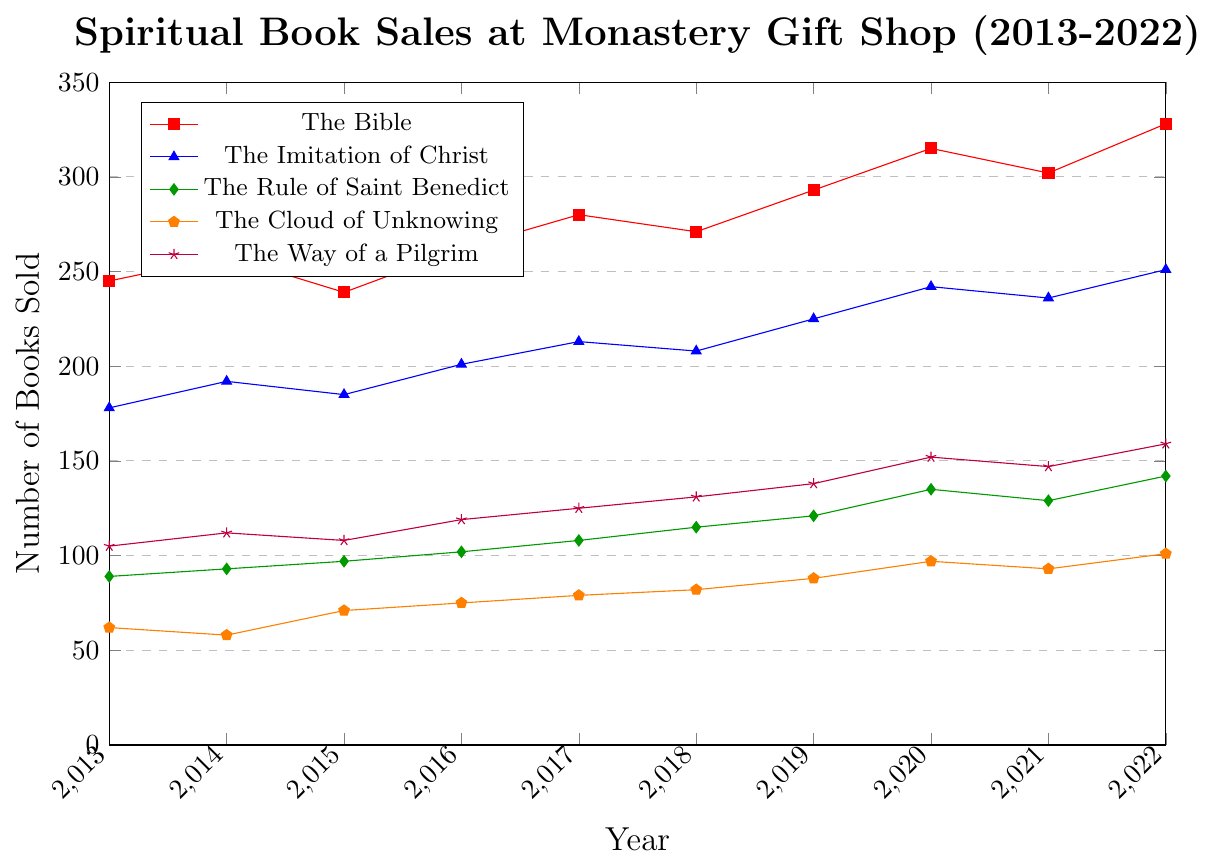What was the difference in sales of "The Bible" between 2013 and 2022? To find the difference, subtract the number of books sold in 2013 from the number of books sold in 2022. The values are 328 in 2022 and 245 in 2013. Therefore, 328 - 245 = 83.
Answer: 83 Which book had the highest sales in 2020 and how many were sold? Scan through the data points for the year 2020. "The Bible" had the highest sales at 315 units.
Answer: The Bible, 315 What was the average number of "The Rule of Saint Benedict" books sold per year over the decade? Sum the sales of "The Rule of Saint Benedict" from 2013 to 2022 and then divide by the number of years, which is 10. The total sales are 89 + 93 + 97 + 102 + 108 + 115 + 121 + 135 + 129 + 142 = 1131. So, 1131 / 10 = 113.1
Answer: 113.1 Which book had the most fluctuating sales pattern over the decade? Observe the changes and fluctuations in the lines for each book over the years. "The Bible" shows larger fluctuations from 239 in 2015 to 315 in 2020, making it the most fluctuating.
Answer: The Bible Between which consecutive years did "The Way of a Pilgrim" see the highest increase in sales? Compare the differences between consecutive years for "The Way of a Pilgrim." The highest increase is from 2019 to 2020, where the sales went from 138 to 152, an increase of 14.
Answer: 2019-2020 In 2017, which book had sales closest to the median of that year's sales across all books? List the sales for all books in 2017: 280, 213, 108, 79, 125. Arrange them in order: 79, 108, 125, 213, 280. The median is 125. "The Way of a Pilgrim" had 125 sales.
Answer: The Way of a Pilgrim Did any book have a decline in sales from 2013 to 2022? Compare the sales in 2013 and 2022 for all books. "The Cloud of Unknowing" had sales of 62 in 2013 and 101 in 2022, indicating an increase. No book shows a decline.
Answer: No What was the total number of "The Imitation of Christ" books sold in 2016 and 2021 combined? Add the sales for "The Imitation of Christ" in 2016 and 2021. The values are 201 and 236 respectively. Thus, 201 + 236 = 437.
Answer: 437 Which book’s sales remained relatively stable over the decade? By visually inspecting the lines, "The Cloud of Unknowing" showed smaller fluctuations and remained relatively stable, especially when compared to others.
Answer: The Cloud of Unknowing 